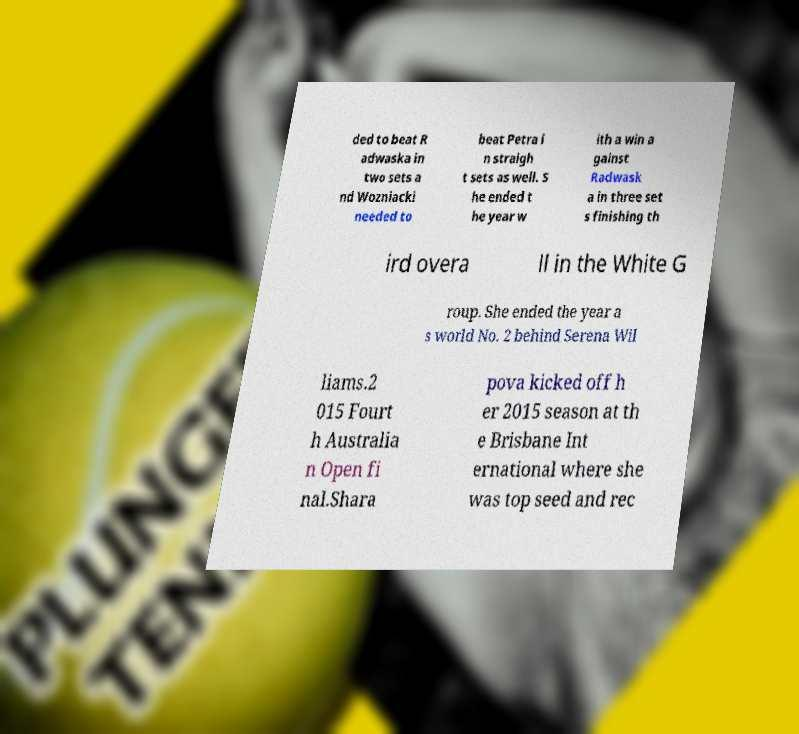Can you accurately transcribe the text from the provided image for me? ded to beat R adwaska in two sets a nd Wozniacki needed to beat Petra i n straigh t sets as well. S he ended t he year w ith a win a gainst Radwask a in three set s finishing th ird overa ll in the White G roup. She ended the year a s world No. 2 behind Serena Wil liams.2 015 Fourt h Australia n Open fi nal.Shara pova kicked off h er 2015 season at th e Brisbane Int ernational where she was top seed and rec 